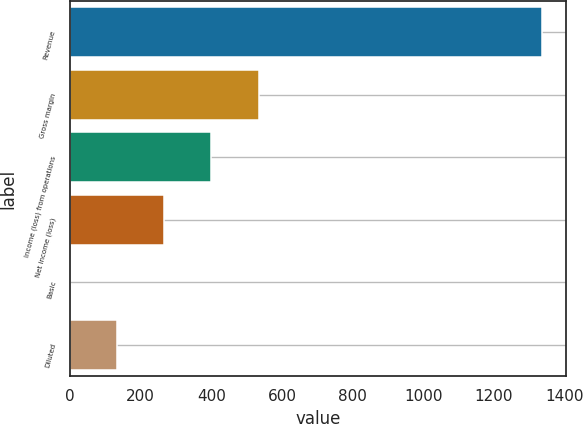<chart> <loc_0><loc_0><loc_500><loc_500><bar_chart><fcel>Revenue<fcel>Gross margin<fcel>Income (loss) from operations<fcel>Net income (loss)<fcel>Basic<fcel>Diluted<nl><fcel>1336<fcel>534.43<fcel>400.84<fcel>267.25<fcel>0.07<fcel>133.66<nl></chart> 